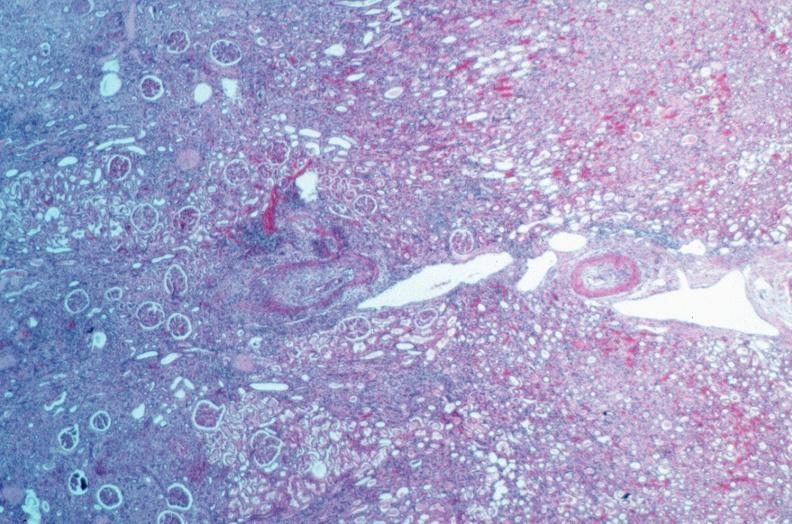what is present?
Answer the question using a single word or phrase. Cardiovascular 